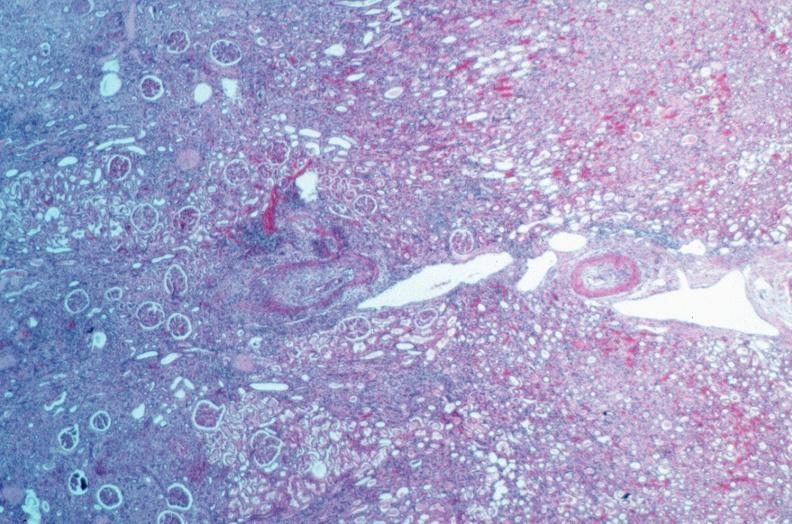what is present?
Answer the question using a single word or phrase. Cardiovascular 